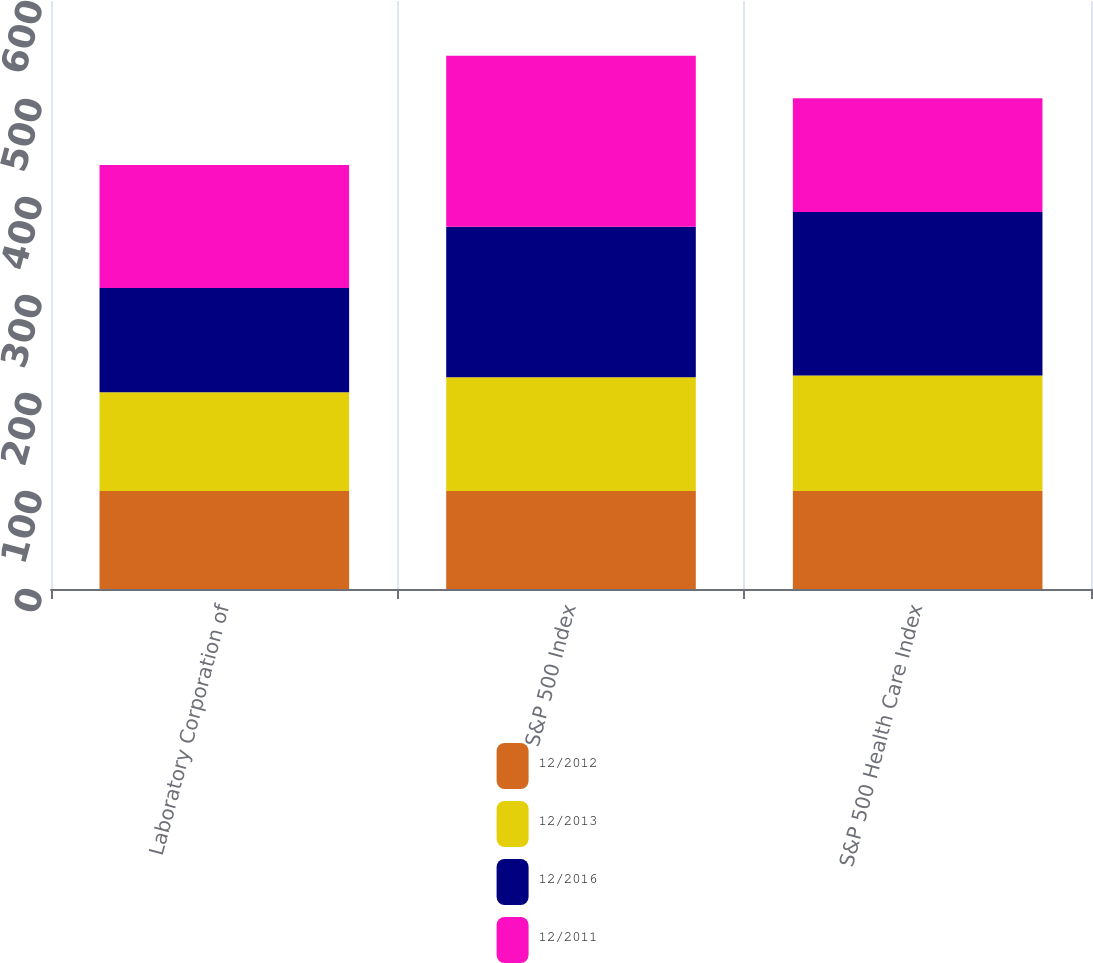<chart> <loc_0><loc_0><loc_500><loc_500><stacked_bar_chart><ecel><fcel>Laboratory Corporation of<fcel>S&P 500 Index<fcel>S&P 500 Health Care Index<nl><fcel>12/2012<fcel>100<fcel>100<fcel>100<nl><fcel>12/2013<fcel>100.76<fcel>116<fcel>117.89<nl><fcel>12/2016<fcel>106.28<fcel>153.57<fcel>166.76<nl><fcel>12/2011<fcel>125.51<fcel>174.6<fcel>116<nl></chart> 